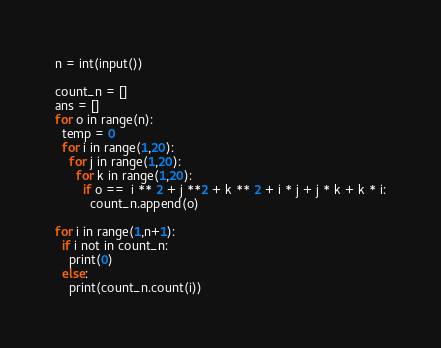Convert code to text. <code><loc_0><loc_0><loc_500><loc_500><_Python_>n = int(input())

count_n = []
ans = []
for o in range(n):
  temp = 0
  for i in range(1,20):
    for j in range(1,20):
      for k in range(1,20):
        if o ==  i ** 2 + j **2 + k ** 2 + i * j + j * k + k * i:
          count_n.append(o)

for i in range(1,n+1):
  if i not in count_n:
    print(0)
  else:
    print(count_n.count(i))</code> 